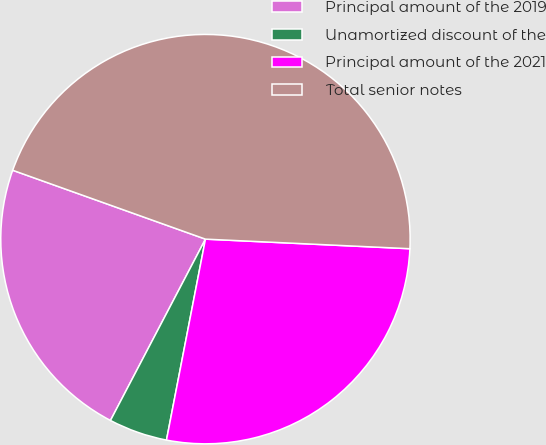Convert chart. <chart><loc_0><loc_0><loc_500><loc_500><pie_chart><fcel>Principal amount of the 2019<fcel>Unamortized discount of the<fcel>Principal amount of the 2021<fcel>Total senior notes<nl><fcel>22.78%<fcel>4.63%<fcel>27.3%<fcel>45.28%<nl></chart> 